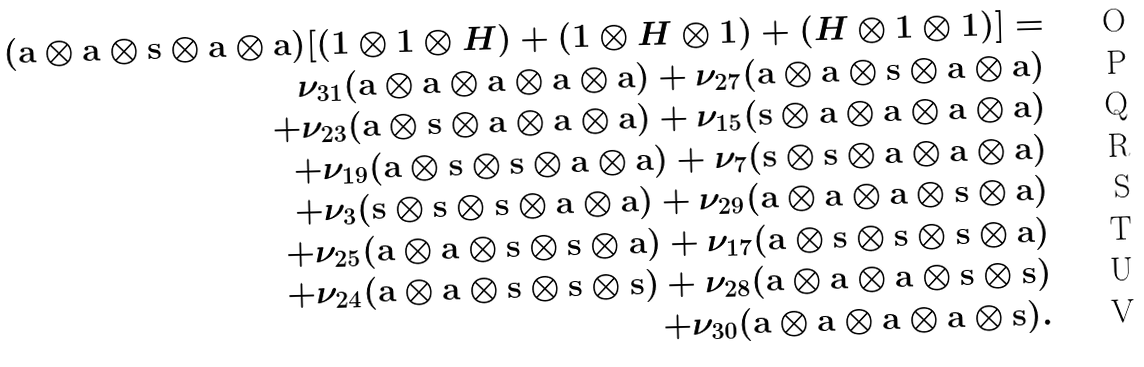<formula> <loc_0><loc_0><loc_500><loc_500>( { \mathbf a } \otimes { \mathbf a } \otimes { \mathbf s } \otimes { \mathbf a } \otimes { \mathbf a } ) [ ( 1 \otimes 1 \otimes H ) + ( 1 \otimes H \otimes 1 ) + ( H \otimes 1 \otimes 1 ) ] = \\ \nu _ { 3 1 } ( { \mathbf a } \otimes { \mathbf a } \otimes { \mathbf a } \otimes { \mathbf a } \otimes { \mathbf a } ) + \nu _ { 2 7 } ( { \mathbf a } \otimes { \mathbf a } \otimes { \mathbf s } \otimes { \mathbf a } \otimes { \mathbf a } ) \\ + \nu _ { 2 3 } ( { \mathbf a } \otimes { \mathbf s } \otimes { \mathbf a } \otimes { \mathbf a } \otimes { \mathbf a } ) + \nu _ { 1 5 } ( { \mathbf s } \otimes { \mathbf a } \otimes { \mathbf a } \otimes { \mathbf a } \otimes { \mathbf a } ) & \\ + \nu _ { 1 9 } ( { \mathbf a } \otimes { \mathbf s } \otimes { \mathbf s } \otimes { \mathbf a } \otimes { \mathbf a } ) + \nu _ { 7 } ( { \mathbf s } \otimes { \mathbf s } \otimes { \mathbf a } \otimes { \mathbf a } \otimes { \mathbf a } ) & \\ + \nu _ { 3 } ( { \mathbf s } \otimes { \mathbf s } \otimes { \mathbf s } \otimes { \mathbf a } \otimes { \mathbf a } ) + \nu _ { 2 9 } ( { \mathbf a } \otimes { \mathbf a } \otimes { \mathbf a } \otimes { \mathbf s } \otimes { \mathbf a } ) & \\ + \nu _ { 2 5 } ( { \mathbf a } \otimes { \mathbf a } \otimes { \mathbf s } \otimes { \mathbf s } \otimes { \mathbf a } ) + \nu _ { 1 7 } ( { \mathbf a } \otimes { \mathbf s } \otimes { \mathbf s } \otimes { \mathbf s } \otimes { \mathbf a } ) & \\ + \nu _ { 2 4 } ( { \mathbf a } \otimes { \mathbf a } \otimes { \mathbf s } \otimes { \mathbf s } \otimes { \mathbf s } ) + \nu _ { 2 8 } ( { \mathbf a } \otimes { \mathbf a } \otimes { \mathbf a } \otimes { \mathbf s } \otimes { \mathbf s } ) & \\ + \nu _ { 3 0 } ( { \mathbf a } \otimes { \mathbf a } \otimes { \mathbf a } \otimes { \mathbf a } \otimes { \mathbf s } ) .</formula> 